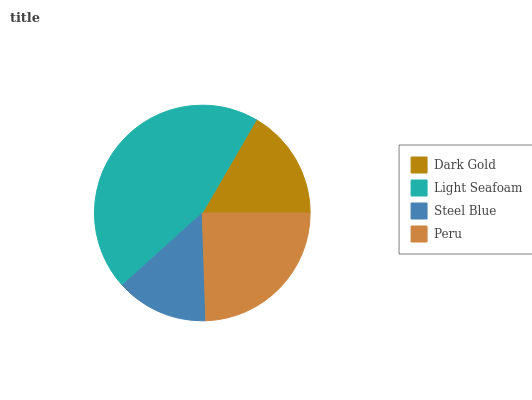Is Steel Blue the minimum?
Answer yes or no. Yes. Is Light Seafoam the maximum?
Answer yes or no. Yes. Is Light Seafoam the minimum?
Answer yes or no. No. Is Steel Blue the maximum?
Answer yes or no. No. Is Light Seafoam greater than Steel Blue?
Answer yes or no. Yes. Is Steel Blue less than Light Seafoam?
Answer yes or no. Yes. Is Steel Blue greater than Light Seafoam?
Answer yes or no. No. Is Light Seafoam less than Steel Blue?
Answer yes or no. No. Is Peru the high median?
Answer yes or no. Yes. Is Dark Gold the low median?
Answer yes or no. Yes. Is Light Seafoam the high median?
Answer yes or no. No. Is Light Seafoam the low median?
Answer yes or no. No. 